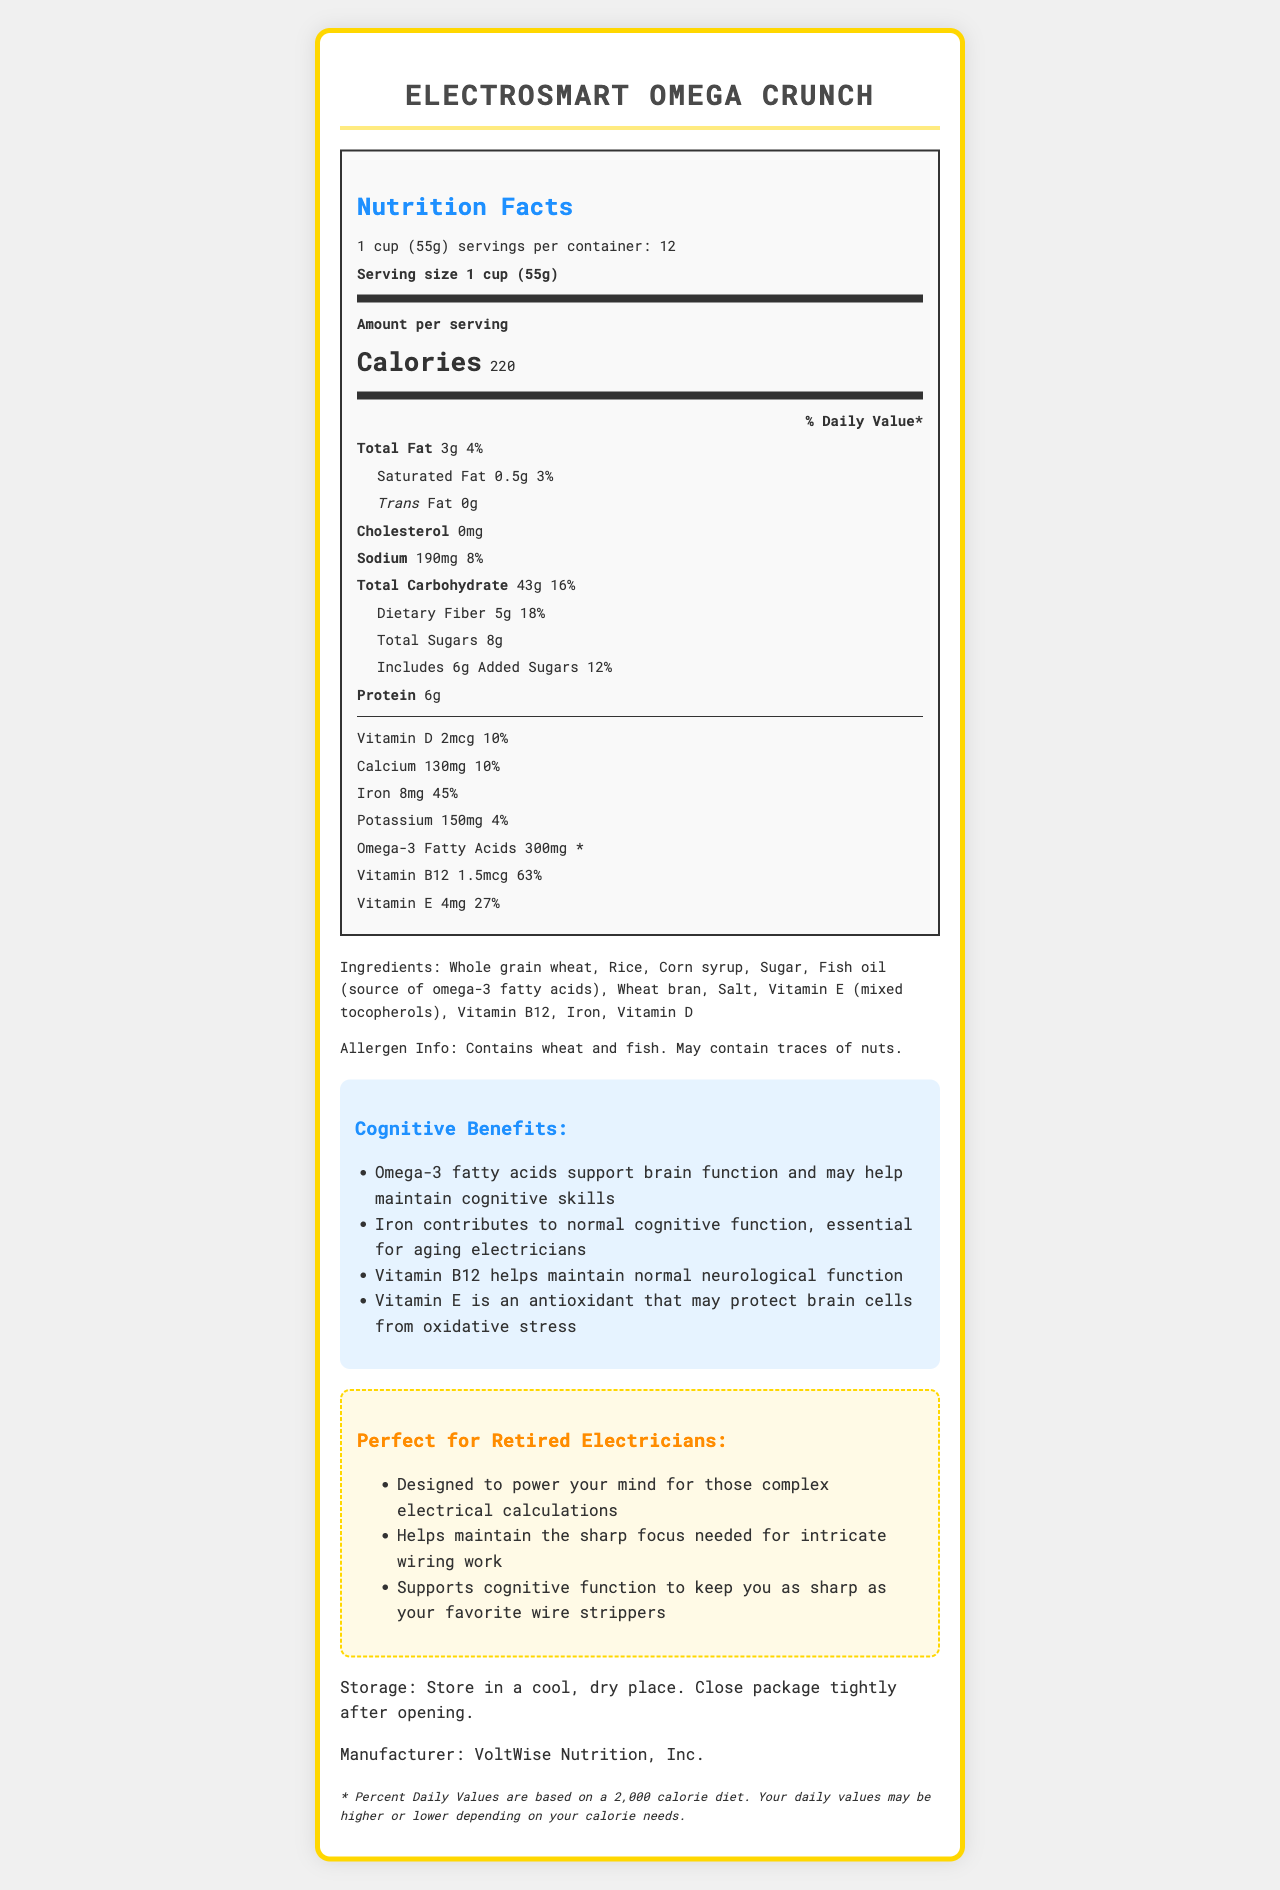what is the serving size? The serving size is explicitly listed in the "Nutrition Facts" section as "1 cup (55g)".
Answer: 1 cup (55g) how many calories per serving? The "Nutrition Facts" section lists the calories per serving as 220.
Answer: 220 Which vitamin has the highest daily value percentage? A. Vitamin D B. Calcium C. Iron D. Vitamin B12 The daily value percentage for Vitamin B12 is 63%, which is higher than Vitamin D (10%), Calcium (10%), and Iron (45%).
Answer: D What is the amount of Omega-3 fatty acids per serving? The "Nutrition Facts" section mentions that each serving contains 300mg of Omega-3 fatty acids.
Answer: 300mg Is this cereal suitable for someone avoiding nuts? The allergen information states that the cereal "May contain traces of nuts."
Answer: No What are the cognitive benefits mentioned for this cereal? The document lists these specific cognitive benefits in the section labeled "Cognitive Benefits."
Answer: Omega-3 fatty acids support brain function and may help maintain cognitive skills, Iron contributes to normal cognitive function, Vitamin B12 helps maintain normal neurological function, Vitamin E is an antioxidant that may protect brain cells from oxidative stress How many servings are in one container? The document states there are 12 servings per container.
Answer: 12 Which nutrient has the highest amount in milligrams? A. Calcium B. Iron C. Sodium D. Potassium Iron has 8mg per serving, while Calcium has 130mg, Sodium 190mg, and Potassium 150mg.
Answer: B What is the daily value percentage of dietary fiber per serving? The "Nutrition Facts" section lists the daily value percentage of dietary fiber as 18%.
Answer: 18% Summarize the main benefits of ElectroSmart Omega Crunch for electricians. The summary includes key points about the cereal's cognitive benefits and appeals to electricians, highlighting the nutritional components that support brain function.
Answer: ElectroSmart Omega Crunch is designed to support brain function and cognitive skills, crucial for retired electricians who need to maintain mental sharpness for complex calculations and intricate tasks. It contains Omega-3 fatty acids, Iron, Vitamin B12, and Vitamin E, all of which contribute to cognitive health. Can the sodium content per serving be determined based on the document? The "Nutrition Facts" section lists the sodium content per serving as 190mg, with a daily value percentage of 8%.
Answer: Yes Who is the manufacturer of ElectroSmart Omega Crunch? The manufacturer is listed at the end of the document as VoltWise Nutrition, Inc.
Answer: VoltWise Nutrition, Inc. What is the storage recommendation for this product? The storage recommendation is provided towards the end of the document.
Answer: Store in a cool, dry place. Close package tightly after opening. Is there a specific section that targets retired electricians? There is a section labeled "Perfect for Retired Electricians" listing specific benefits for this group.
Answer: Yes What is the total fat content per serving? The "Nutrition Facts" section states the total fat content per serving as 3g.
Answer: 3g What is the primary ingredient listed? The primary ingredient listed is "Whole grain wheat."
Answer: Whole grain wheat How many grams of protein are in one serving? The "Nutrition Facts" section lists the protein content per serving as 6g.
Answer: 6g Which benefits are associated with Vitamin E, according to the document? This benefit is explicitly stated in the "Cognitive Benefits" section.
Answer: Vitamin E is an antioxidant that may protect brain cells from oxidative stress. Does the document specify the source of Omega-3 fatty acids? The document specifies that the source of Omega-3 fatty acids is fish oil.
Answer: Yes What is the percentage daily value of Iron per serving? The "Nutrition Facts" section lists the daily value percentage for Iron as 45%.
Answer: 45% What are the potential allergens in this cereal? The allergen information section states that the cereal contains wheat and fish and may contain traces of nuts.
Answer: Wheat and fish Is there a disclaimer related to daily values? The disclaimer states, "* Percent Daily Values are based on a 2,000 calorie diet. Your daily values may be higher or lower depending on your calorie needs."
Answer: Yes What type of oil is used as a source of Omega-3 fatty acids? The ingredients list mentions fish oil as the source of Omega-3 fatty acids.
Answer: Fish oil 